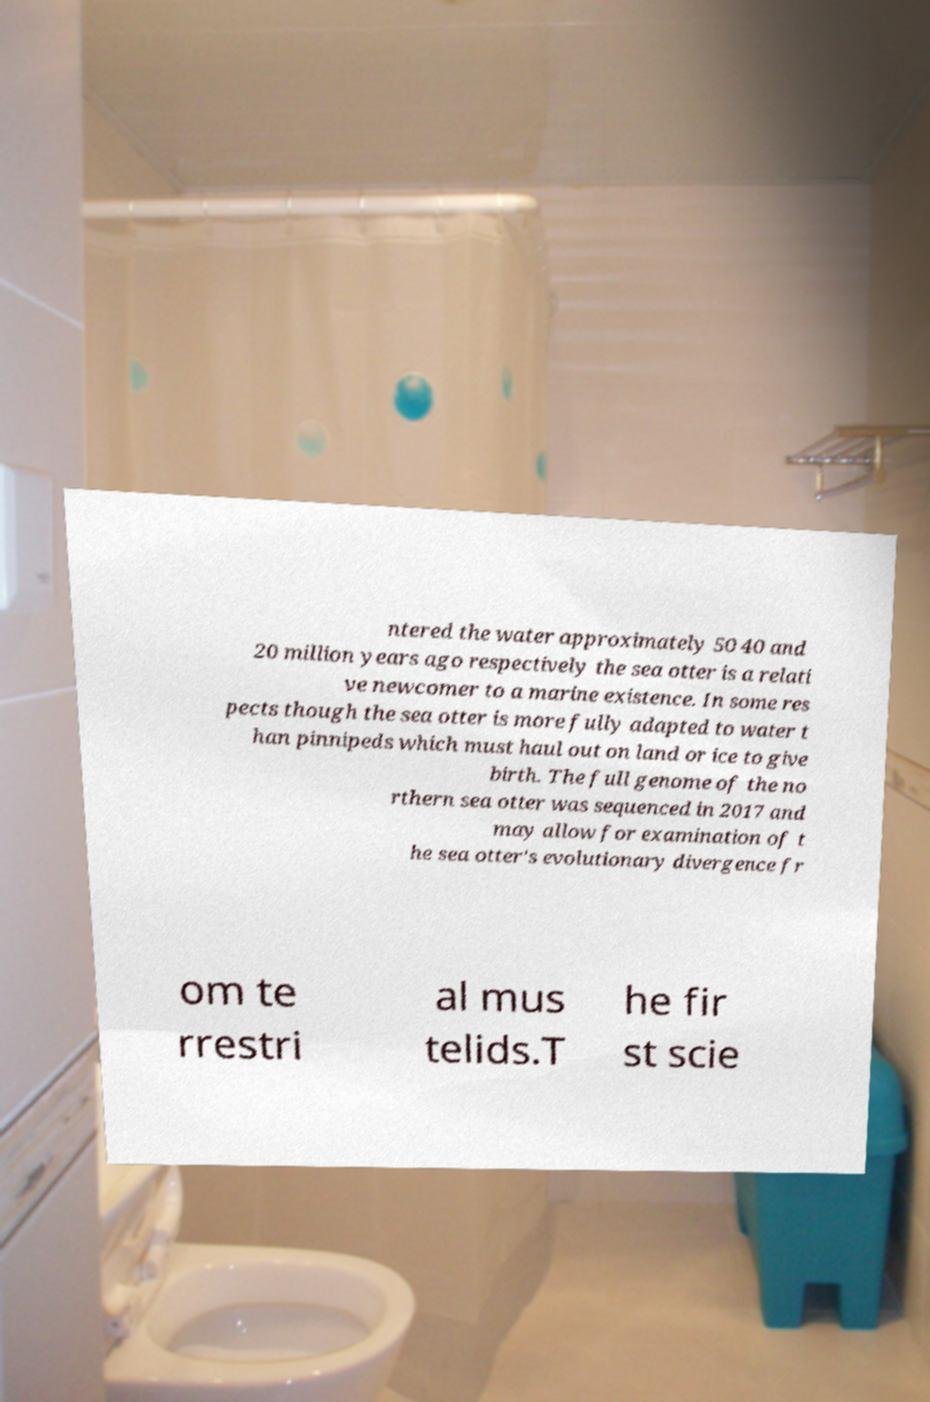Please read and relay the text visible in this image. What does it say? ntered the water approximately 50 40 and 20 million years ago respectively the sea otter is a relati ve newcomer to a marine existence. In some res pects though the sea otter is more fully adapted to water t han pinnipeds which must haul out on land or ice to give birth. The full genome of the no rthern sea otter was sequenced in 2017 and may allow for examination of t he sea otter's evolutionary divergence fr om te rrestri al mus telids.T he fir st scie 